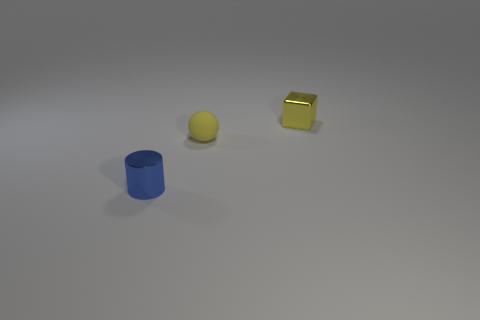Add 2 cubes. How many objects exist? 5 Subtract all balls. How many objects are left? 2 Subtract all yellow metallic blocks. Subtract all tiny purple metal cylinders. How many objects are left? 2 Add 1 rubber balls. How many rubber balls are left? 2 Add 3 small blue balls. How many small blue balls exist? 3 Subtract 0 gray cubes. How many objects are left? 3 